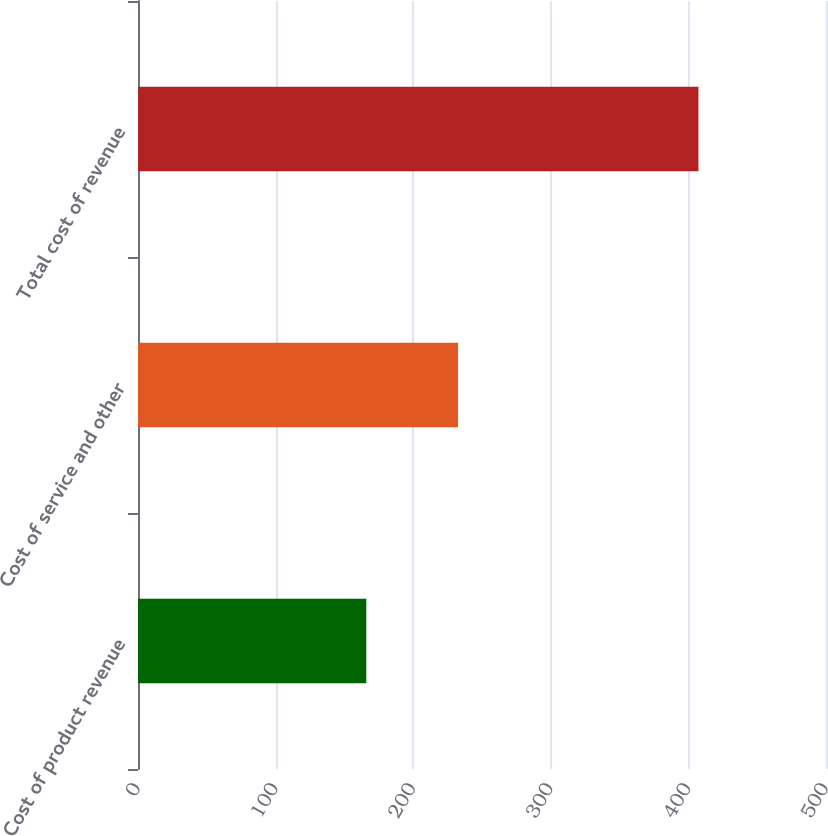Convert chart to OTSL. <chart><loc_0><loc_0><loc_500><loc_500><bar_chart><fcel>Cost of product revenue<fcel>Cost of service and other<fcel>Total cost of revenue<nl><fcel>165.9<fcel>232.6<fcel>407.3<nl></chart> 